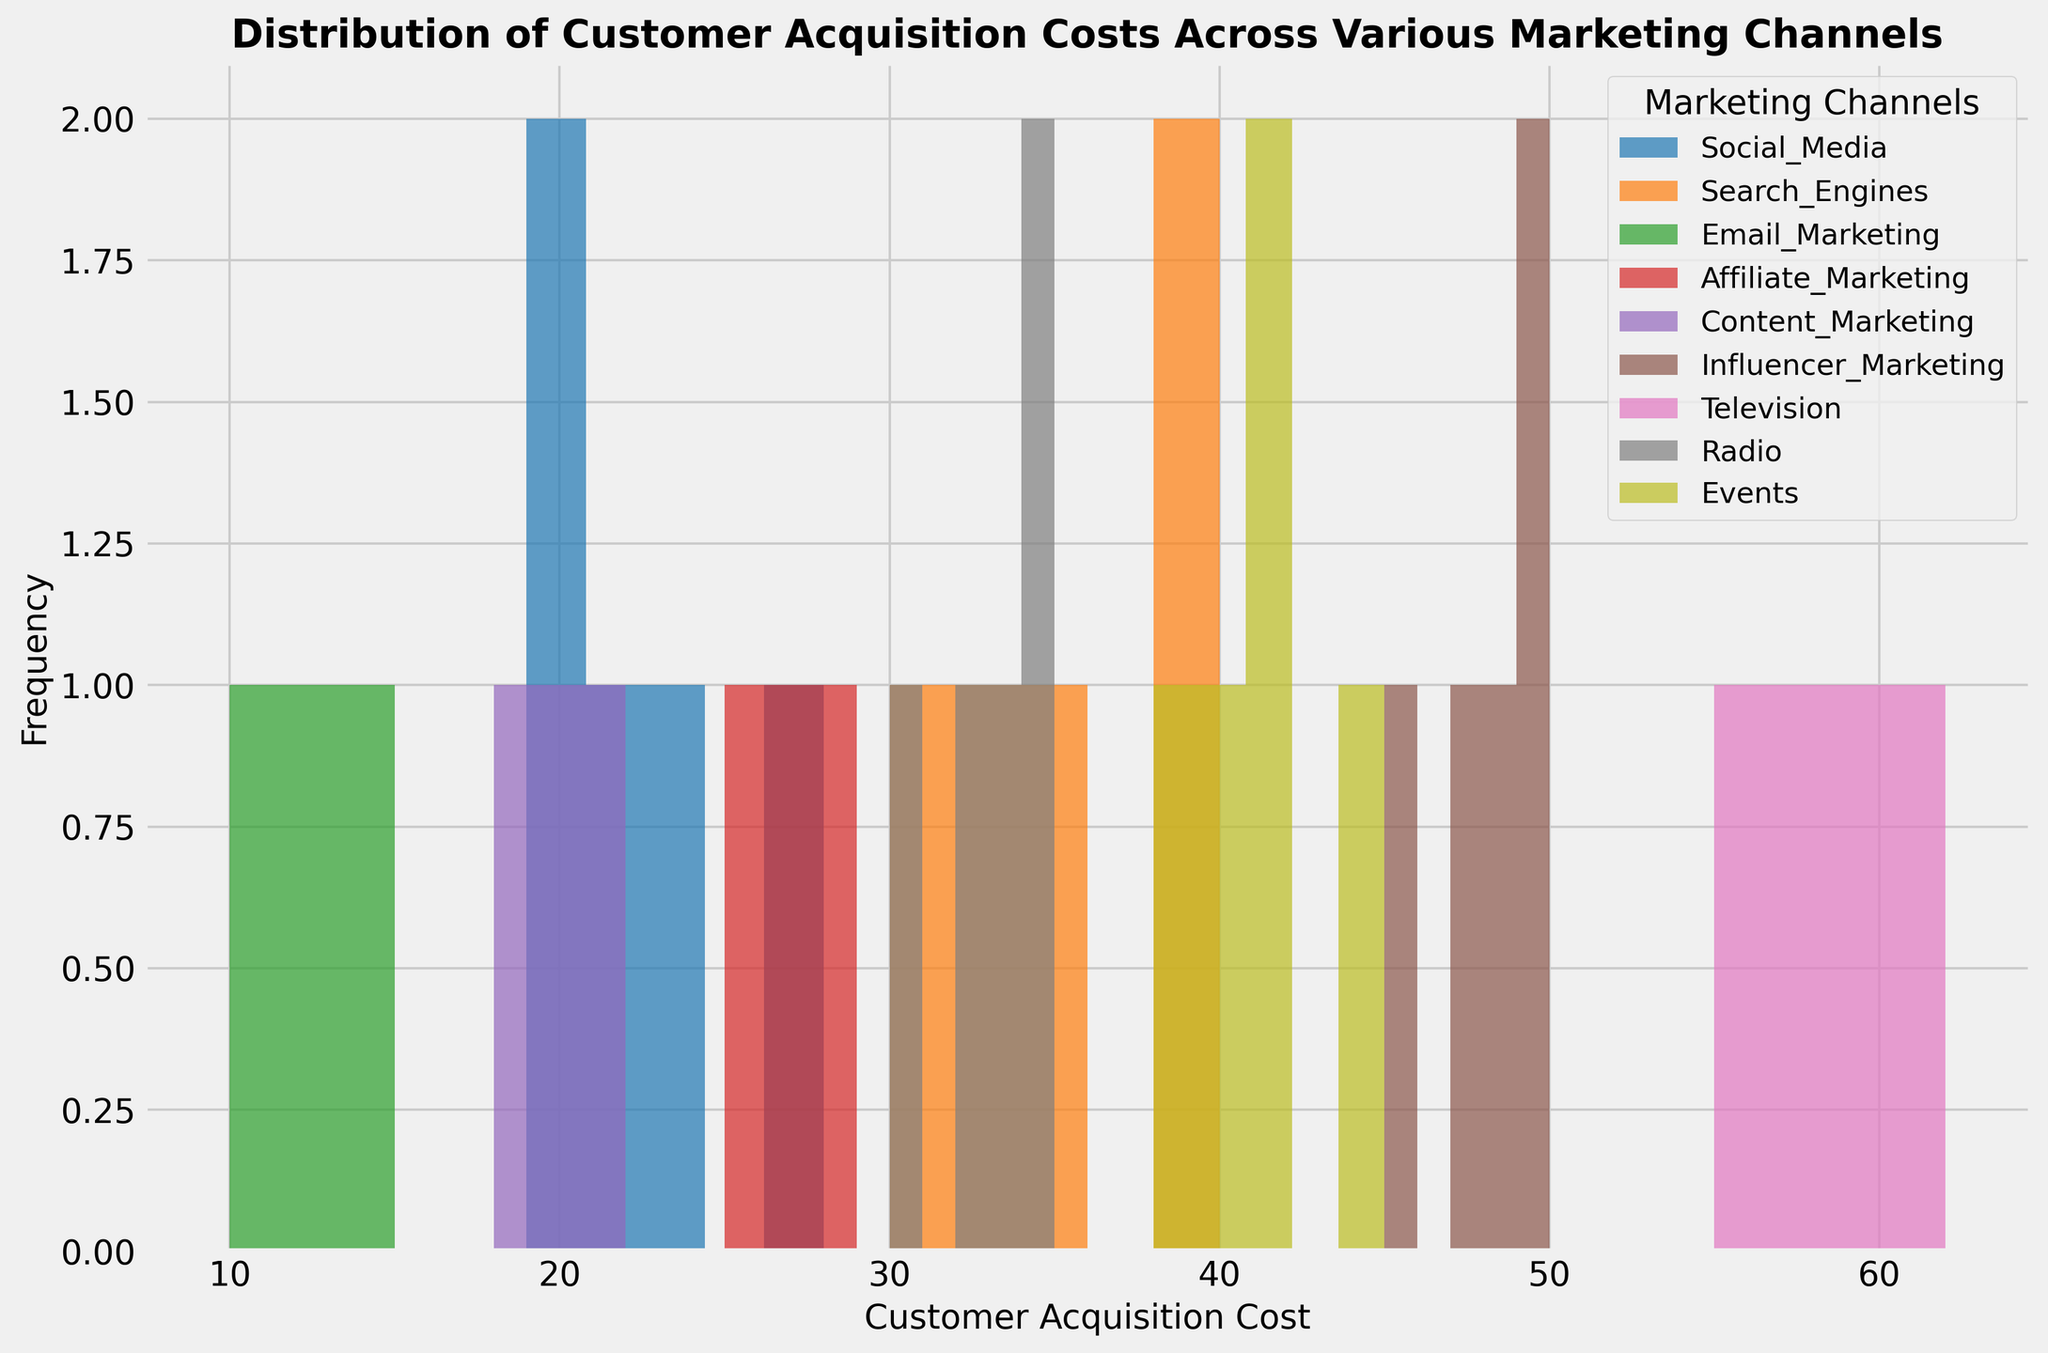How many marketing channels have a Customer Acquisition Cost that appears only in one bin? To answer this, we look for marketing channels whose histogram bars only appear in a single bin. These include channels where the cost data points are tightly clustered around a narrow range. By inspecting the number of filled bins for each channel color, we see only Email Marketing (green) fits this description.
Answer: 1 Which marketing channel has the widest distribution of Customer Acquisition Costs? The widest distribution is represented by marketing channels with the largest spread of histogram bars across the x-axis. Television (pink) shows bars starting from around 55 to 62, indicating the widest distribution range.
Answer: Television What's the difference between the highest Customer Acquisition Cost for Influencer Marketing and the lowest Customer Acquisition Cost for Social Media? Influencer Marketing's highest cost is in the last bin, approximately 50. Social Media's lowest cost is in the first bin, approximately 19. The difference is 50 - 19.
Answer: 31 Which marketing channel appears to have the lowest average Customer Acquisition Cost? The lowest average cost can be inferred from the visual location of histogram bars clustered toward lower values on the x-axis. Email Marketing (green) has bars around the 10-15 range, indicating it has the lowest average cost.
Answer: Email Marketing How many bins are occupied by Search Engines' Customer Acquisition Cost data? Search Engines' bars (orange) are observed between the x-range 30 to 40. The bars fall into bins within this range so we count the bars from 30 up to 40. It occupies 3 bins.
Answer: 3 Which marketing channel seems most cost-effective based on the height of the bars in the lower range of Customer Acquisition Costs? Bars representing higher frequencies of low customer acquisition costs indicate cost-effectiveness. Email Marketing (green) has bars clustered around lower costs with relatively high bars.
Answer: Email Marketing What's the total number of bins occupied by Events and Content Marketing together? Inspecting visually, Events (yellow) has bars from around 38 to 45 and Content Marketing (purple) has bars from around 18 to 22. Counting these bins, Events occupy 4 and Content Marketing 3 bins. Totaling these, we get 4 + 3.
Answer: 7 Which marketing channels have overlapping Customer Acquisition Costs in the bins around 30s? We look for channels with bars appearing in the 30 ranges. Social Media (blue) and Radio (grey) share bins around 30–35. Search Engines occupy slightly higher adjacent bins.
Answer: Social Media, Radio, and Search Engines How does the cost distribution of radio advertising compare to television advertising? Radio (grey) has bars from around 30 to 35, while Television (pink) from around 55 to 62. Both have multiple bins, but Television stands out with higher cost ranges. Visually, Television spans a higher cost range and number of bins.
Answer: Radio: moderate, Television: higher 